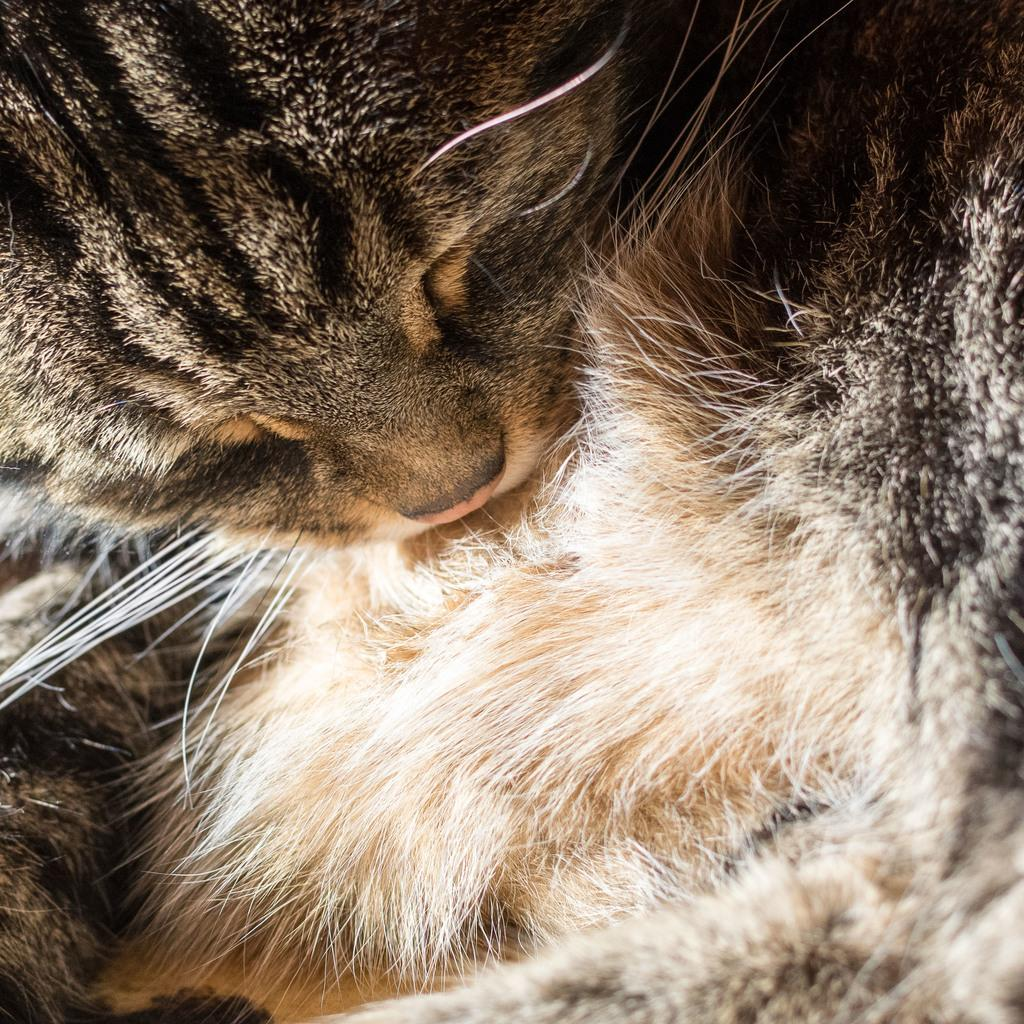What type of animal is in the image? There is a cat in the image. What part of the cat is the focus of the image? The image provides a close view of the cat's mouth. What type of berry can be seen growing near the cat in the image? There is no berry present in the image, and the cat is not near any plants or vegetation. 